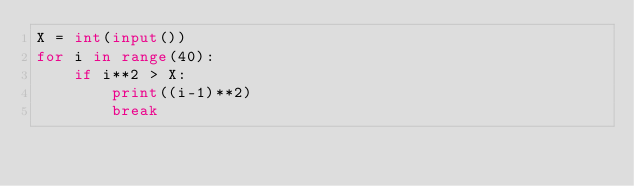Convert code to text. <code><loc_0><loc_0><loc_500><loc_500><_Python_>X = int(input())
for i in range(40):
    if i**2 > X:
        print((i-1)**2)
        break</code> 